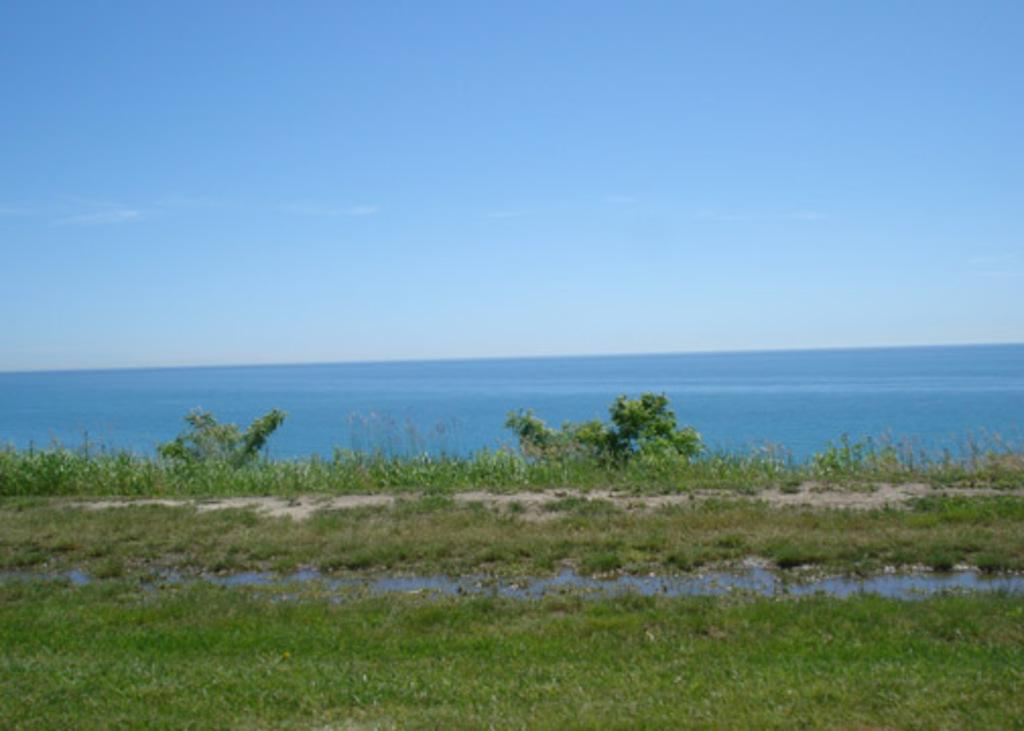What type of natural environment is visible in the image? There is grass and plants visible in the image. What can be seen in the image besides the grass and plants? There is water visible in the image. What part of the natural environment is visible in the background of the image? The sky is visible in the background of the image. What type of noise can be heard coming from the grass in the image? There is no indication of any noise in the image, as it features a natural environment with grass, plants, water, and the sky. What type of jam is being spread on the plants in the image? There is no jam or any indication of food items being used on the plants in the image. 